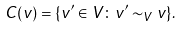<formula> <loc_0><loc_0><loc_500><loc_500>C ( v ) = \{ v ^ { \prime } \in V \colon v ^ { \prime } \sim _ { V } v \} .</formula> 